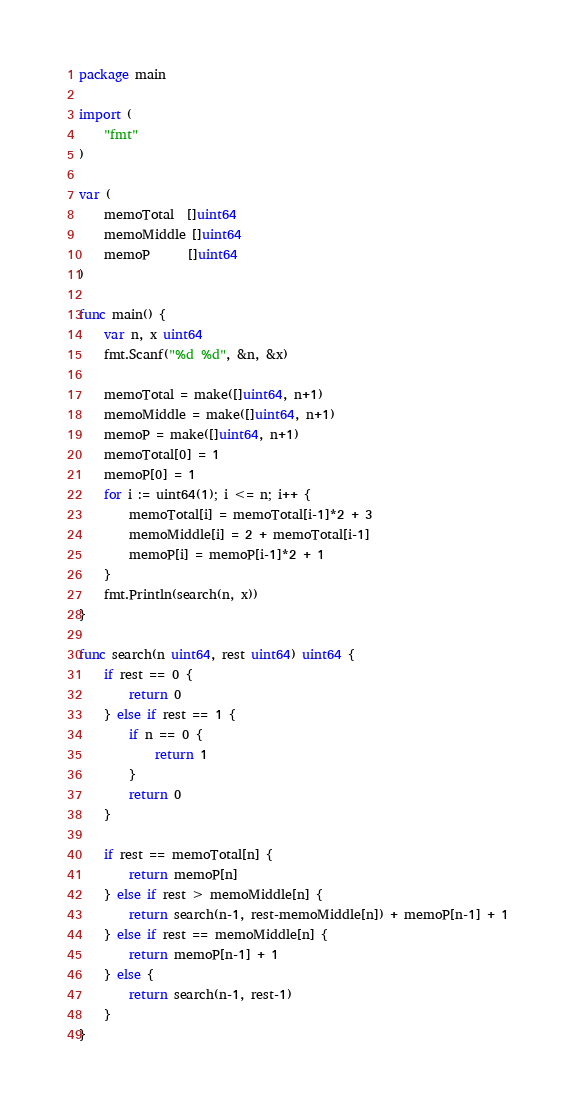<code> <loc_0><loc_0><loc_500><loc_500><_Go_>package main

import (
	"fmt"
)

var (
	memoTotal  []uint64
	memoMiddle []uint64
	memoP      []uint64
)

func main() {
	var n, x uint64
	fmt.Scanf("%d %d", &n, &x)

	memoTotal = make([]uint64, n+1)
	memoMiddle = make([]uint64, n+1)
	memoP = make([]uint64, n+1)
	memoTotal[0] = 1
	memoP[0] = 1
	for i := uint64(1); i <= n; i++ {
		memoTotal[i] = memoTotal[i-1]*2 + 3
		memoMiddle[i] = 2 + memoTotal[i-1]
		memoP[i] = memoP[i-1]*2 + 1
	}
	fmt.Println(search(n, x))
}

func search(n uint64, rest uint64) uint64 {
	if rest == 0 {
		return 0
	} else if rest == 1 {
		if n == 0 {
			return 1
		}
		return 0
	}

	if rest == memoTotal[n] {
		return memoP[n]
	} else if rest > memoMiddle[n] {
		return search(n-1, rest-memoMiddle[n]) + memoP[n-1] + 1
	} else if rest == memoMiddle[n] {
		return memoP[n-1] + 1
	} else {
		return search(n-1, rest-1)
	}
}
</code> 